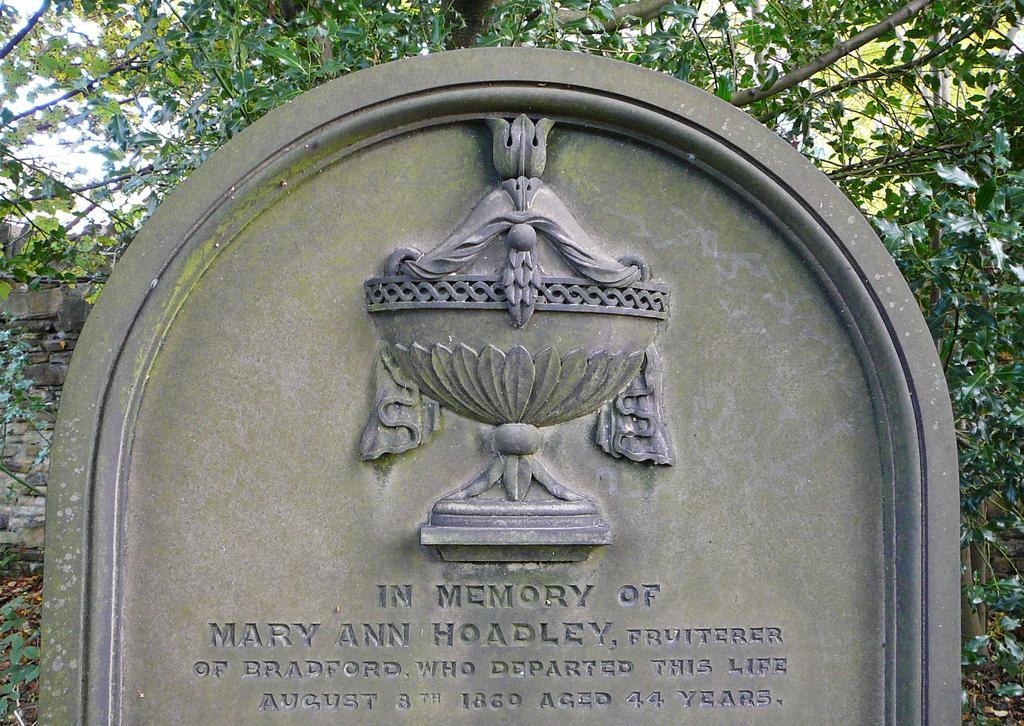How would you summarize this image in a sentence or two? In the foreground of the picture I can see the memorial rock. I can see the wall on the left side. In the background, I can see the trees. 